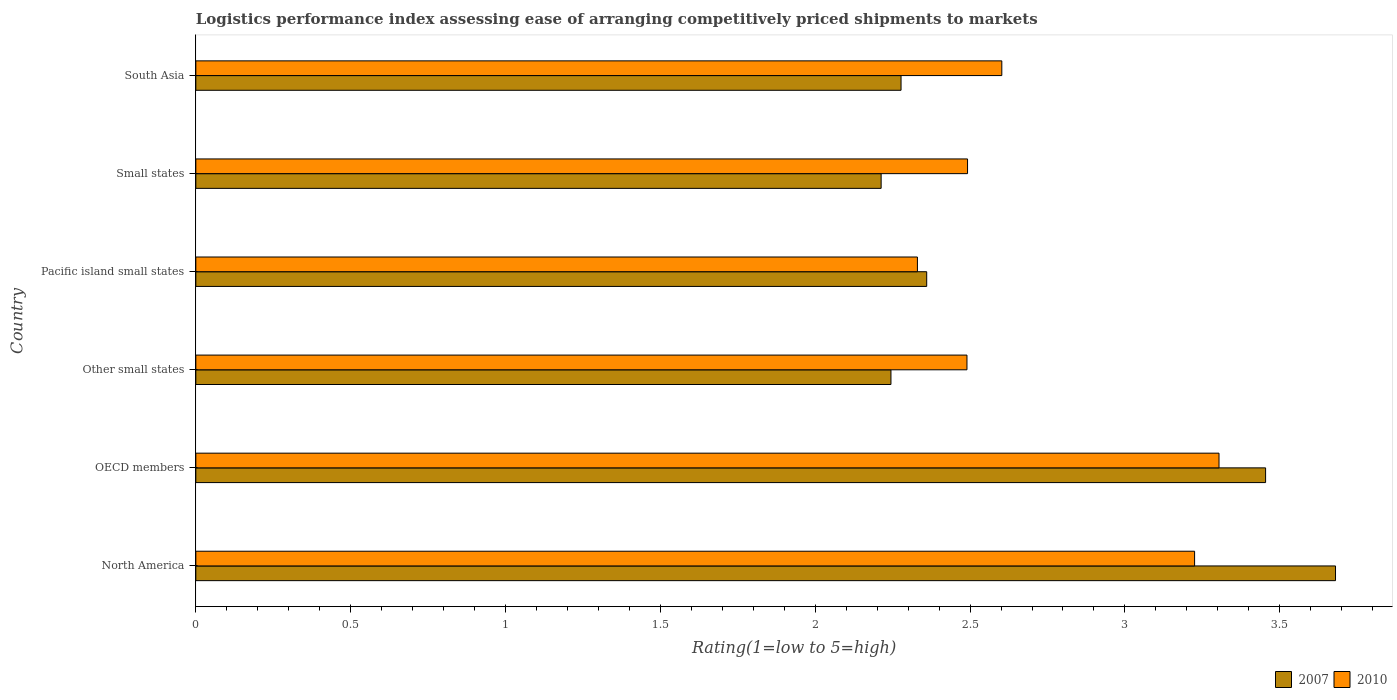How many groups of bars are there?
Offer a terse response. 6. What is the label of the 6th group of bars from the top?
Ensure brevity in your answer.  North America. In how many cases, is the number of bars for a given country not equal to the number of legend labels?
Provide a short and direct response. 0. What is the Logistic performance index in 2010 in North America?
Your answer should be very brief. 3.23. Across all countries, what is the maximum Logistic performance index in 2010?
Provide a succinct answer. 3.3. Across all countries, what is the minimum Logistic performance index in 2007?
Your answer should be compact. 2.21. In which country was the Logistic performance index in 2007 minimum?
Provide a short and direct response. Small states. What is the total Logistic performance index in 2007 in the graph?
Your answer should be very brief. 16.23. What is the difference between the Logistic performance index in 2010 in North America and that in Other small states?
Provide a short and direct response. 0.73. What is the difference between the Logistic performance index in 2010 in South Asia and the Logistic performance index in 2007 in OECD members?
Provide a short and direct response. -0.85. What is the average Logistic performance index in 2007 per country?
Your response must be concise. 2.7. What is the difference between the Logistic performance index in 2007 and Logistic performance index in 2010 in Other small states?
Offer a very short reply. -0.25. What is the ratio of the Logistic performance index in 2007 in Other small states to that in Small states?
Give a very brief answer. 1.01. Is the Logistic performance index in 2007 in OECD members less than that in Other small states?
Provide a succinct answer. No. What is the difference between the highest and the second highest Logistic performance index in 2007?
Offer a very short reply. 0.23. What is the difference between the highest and the lowest Logistic performance index in 2007?
Your answer should be very brief. 1.47. In how many countries, is the Logistic performance index in 2010 greater than the average Logistic performance index in 2010 taken over all countries?
Your answer should be very brief. 2. How many bars are there?
Your answer should be compact. 12. Are all the bars in the graph horizontal?
Give a very brief answer. Yes. How many countries are there in the graph?
Offer a very short reply. 6. Are the values on the major ticks of X-axis written in scientific E-notation?
Keep it short and to the point. No. Where does the legend appear in the graph?
Your answer should be very brief. Bottom right. How many legend labels are there?
Provide a short and direct response. 2. How are the legend labels stacked?
Ensure brevity in your answer.  Horizontal. What is the title of the graph?
Make the answer very short. Logistics performance index assessing ease of arranging competitively priced shipments to markets. What is the label or title of the X-axis?
Ensure brevity in your answer.  Rating(1=low to 5=high). What is the label or title of the Y-axis?
Make the answer very short. Country. What is the Rating(1=low to 5=high) in 2007 in North America?
Offer a very short reply. 3.68. What is the Rating(1=low to 5=high) in 2010 in North America?
Your response must be concise. 3.23. What is the Rating(1=low to 5=high) of 2007 in OECD members?
Offer a very short reply. 3.45. What is the Rating(1=low to 5=high) of 2010 in OECD members?
Your answer should be compact. 3.3. What is the Rating(1=low to 5=high) of 2007 in Other small states?
Give a very brief answer. 2.24. What is the Rating(1=low to 5=high) in 2010 in Other small states?
Offer a terse response. 2.49. What is the Rating(1=low to 5=high) of 2007 in Pacific island small states?
Ensure brevity in your answer.  2.36. What is the Rating(1=low to 5=high) in 2010 in Pacific island small states?
Offer a very short reply. 2.33. What is the Rating(1=low to 5=high) of 2007 in Small states?
Keep it short and to the point. 2.21. What is the Rating(1=low to 5=high) in 2010 in Small states?
Your response must be concise. 2.49. What is the Rating(1=low to 5=high) in 2007 in South Asia?
Keep it short and to the point. 2.28. What is the Rating(1=low to 5=high) in 2010 in South Asia?
Your answer should be compact. 2.6. Across all countries, what is the maximum Rating(1=low to 5=high) of 2007?
Your response must be concise. 3.68. Across all countries, what is the maximum Rating(1=low to 5=high) in 2010?
Your response must be concise. 3.3. Across all countries, what is the minimum Rating(1=low to 5=high) of 2007?
Your answer should be compact. 2.21. Across all countries, what is the minimum Rating(1=low to 5=high) of 2010?
Ensure brevity in your answer.  2.33. What is the total Rating(1=low to 5=high) of 2007 in the graph?
Provide a short and direct response. 16.23. What is the total Rating(1=low to 5=high) of 2010 in the graph?
Provide a short and direct response. 16.44. What is the difference between the Rating(1=low to 5=high) in 2007 in North America and that in OECD members?
Offer a very short reply. 0.23. What is the difference between the Rating(1=low to 5=high) in 2010 in North America and that in OECD members?
Make the answer very short. -0.08. What is the difference between the Rating(1=low to 5=high) in 2007 in North America and that in Other small states?
Your answer should be very brief. 1.44. What is the difference between the Rating(1=low to 5=high) of 2010 in North America and that in Other small states?
Offer a terse response. 0.73. What is the difference between the Rating(1=low to 5=high) of 2007 in North America and that in Pacific island small states?
Ensure brevity in your answer.  1.32. What is the difference between the Rating(1=low to 5=high) in 2010 in North America and that in Pacific island small states?
Make the answer very short. 0.9. What is the difference between the Rating(1=low to 5=high) of 2007 in North America and that in Small states?
Offer a very short reply. 1.47. What is the difference between the Rating(1=low to 5=high) in 2010 in North America and that in Small states?
Your answer should be very brief. 0.73. What is the difference between the Rating(1=low to 5=high) in 2007 in North America and that in South Asia?
Offer a very short reply. 1.4. What is the difference between the Rating(1=low to 5=high) in 2010 in North America and that in South Asia?
Make the answer very short. 0.62. What is the difference between the Rating(1=low to 5=high) in 2007 in OECD members and that in Other small states?
Offer a very short reply. 1.21. What is the difference between the Rating(1=low to 5=high) of 2010 in OECD members and that in Other small states?
Ensure brevity in your answer.  0.81. What is the difference between the Rating(1=low to 5=high) of 2007 in OECD members and that in Pacific island small states?
Offer a terse response. 1.09. What is the difference between the Rating(1=low to 5=high) of 2010 in OECD members and that in Pacific island small states?
Your answer should be very brief. 0.97. What is the difference between the Rating(1=low to 5=high) in 2007 in OECD members and that in Small states?
Provide a succinct answer. 1.24. What is the difference between the Rating(1=low to 5=high) in 2010 in OECD members and that in Small states?
Your answer should be very brief. 0.81. What is the difference between the Rating(1=low to 5=high) of 2007 in OECD members and that in South Asia?
Your answer should be compact. 1.18. What is the difference between the Rating(1=low to 5=high) in 2010 in OECD members and that in South Asia?
Give a very brief answer. 0.7. What is the difference between the Rating(1=low to 5=high) in 2007 in Other small states and that in Pacific island small states?
Make the answer very short. -0.12. What is the difference between the Rating(1=low to 5=high) in 2010 in Other small states and that in Pacific island small states?
Ensure brevity in your answer.  0.16. What is the difference between the Rating(1=low to 5=high) of 2007 in Other small states and that in Small states?
Provide a short and direct response. 0.03. What is the difference between the Rating(1=low to 5=high) in 2010 in Other small states and that in Small states?
Offer a very short reply. -0. What is the difference between the Rating(1=low to 5=high) in 2007 in Other small states and that in South Asia?
Ensure brevity in your answer.  -0.03. What is the difference between the Rating(1=low to 5=high) in 2010 in Other small states and that in South Asia?
Ensure brevity in your answer.  -0.11. What is the difference between the Rating(1=low to 5=high) of 2007 in Pacific island small states and that in Small states?
Your response must be concise. 0.15. What is the difference between the Rating(1=low to 5=high) of 2010 in Pacific island small states and that in Small states?
Your answer should be very brief. -0.16. What is the difference between the Rating(1=low to 5=high) in 2007 in Pacific island small states and that in South Asia?
Ensure brevity in your answer.  0.08. What is the difference between the Rating(1=low to 5=high) in 2010 in Pacific island small states and that in South Asia?
Your answer should be very brief. -0.27. What is the difference between the Rating(1=low to 5=high) of 2007 in Small states and that in South Asia?
Ensure brevity in your answer.  -0.06. What is the difference between the Rating(1=low to 5=high) of 2010 in Small states and that in South Asia?
Your answer should be compact. -0.11. What is the difference between the Rating(1=low to 5=high) in 2007 in North America and the Rating(1=low to 5=high) in 2010 in OECD members?
Keep it short and to the point. 0.38. What is the difference between the Rating(1=low to 5=high) of 2007 in North America and the Rating(1=low to 5=high) of 2010 in Other small states?
Keep it short and to the point. 1.19. What is the difference between the Rating(1=low to 5=high) of 2007 in North America and the Rating(1=low to 5=high) of 2010 in Pacific island small states?
Offer a terse response. 1.35. What is the difference between the Rating(1=low to 5=high) in 2007 in North America and the Rating(1=low to 5=high) in 2010 in Small states?
Your answer should be compact. 1.19. What is the difference between the Rating(1=low to 5=high) in 2007 in North America and the Rating(1=low to 5=high) in 2010 in South Asia?
Provide a short and direct response. 1.08. What is the difference between the Rating(1=low to 5=high) of 2007 in OECD members and the Rating(1=low to 5=high) of 2010 in Other small states?
Your response must be concise. 0.96. What is the difference between the Rating(1=low to 5=high) of 2007 in OECD members and the Rating(1=low to 5=high) of 2010 in Pacific island small states?
Your answer should be very brief. 1.12. What is the difference between the Rating(1=low to 5=high) in 2007 in OECD members and the Rating(1=low to 5=high) in 2010 in Small states?
Provide a succinct answer. 0.96. What is the difference between the Rating(1=low to 5=high) of 2007 in OECD members and the Rating(1=low to 5=high) of 2010 in South Asia?
Ensure brevity in your answer.  0.85. What is the difference between the Rating(1=low to 5=high) of 2007 in Other small states and the Rating(1=low to 5=high) of 2010 in Pacific island small states?
Provide a short and direct response. -0.09. What is the difference between the Rating(1=low to 5=high) of 2007 in Other small states and the Rating(1=low to 5=high) of 2010 in Small states?
Provide a succinct answer. -0.25. What is the difference between the Rating(1=low to 5=high) in 2007 in Other small states and the Rating(1=low to 5=high) in 2010 in South Asia?
Offer a very short reply. -0.36. What is the difference between the Rating(1=low to 5=high) in 2007 in Pacific island small states and the Rating(1=low to 5=high) in 2010 in Small states?
Give a very brief answer. -0.13. What is the difference between the Rating(1=low to 5=high) in 2007 in Pacific island small states and the Rating(1=low to 5=high) in 2010 in South Asia?
Offer a very short reply. -0.24. What is the difference between the Rating(1=low to 5=high) in 2007 in Small states and the Rating(1=low to 5=high) in 2010 in South Asia?
Make the answer very short. -0.39. What is the average Rating(1=low to 5=high) in 2007 per country?
Your response must be concise. 2.7. What is the average Rating(1=low to 5=high) of 2010 per country?
Provide a short and direct response. 2.74. What is the difference between the Rating(1=low to 5=high) of 2007 and Rating(1=low to 5=high) of 2010 in North America?
Your answer should be compact. 0.46. What is the difference between the Rating(1=low to 5=high) of 2007 and Rating(1=low to 5=high) of 2010 in OECD members?
Offer a very short reply. 0.15. What is the difference between the Rating(1=low to 5=high) in 2007 and Rating(1=low to 5=high) in 2010 in Other small states?
Provide a succinct answer. -0.25. What is the difference between the Rating(1=low to 5=high) in 2007 and Rating(1=low to 5=high) in 2010 in Pacific island small states?
Make the answer very short. 0.03. What is the difference between the Rating(1=low to 5=high) of 2007 and Rating(1=low to 5=high) of 2010 in Small states?
Provide a short and direct response. -0.28. What is the difference between the Rating(1=low to 5=high) of 2007 and Rating(1=low to 5=high) of 2010 in South Asia?
Provide a short and direct response. -0.33. What is the ratio of the Rating(1=low to 5=high) of 2007 in North America to that in OECD members?
Ensure brevity in your answer.  1.07. What is the ratio of the Rating(1=low to 5=high) in 2010 in North America to that in OECD members?
Provide a succinct answer. 0.98. What is the ratio of the Rating(1=low to 5=high) of 2007 in North America to that in Other small states?
Provide a short and direct response. 1.64. What is the ratio of the Rating(1=low to 5=high) in 2010 in North America to that in Other small states?
Your answer should be very brief. 1.3. What is the ratio of the Rating(1=low to 5=high) in 2007 in North America to that in Pacific island small states?
Keep it short and to the point. 1.56. What is the ratio of the Rating(1=low to 5=high) in 2010 in North America to that in Pacific island small states?
Offer a terse response. 1.38. What is the ratio of the Rating(1=low to 5=high) of 2007 in North America to that in Small states?
Provide a succinct answer. 1.66. What is the ratio of the Rating(1=low to 5=high) in 2010 in North America to that in Small states?
Your answer should be compact. 1.29. What is the ratio of the Rating(1=low to 5=high) in 2007 in North America to that in South Asia?
Provide a succinct answer. 1.62. What is the ratio of the Rating(1=low to 5=high) of 2010 in North America to that in South Asia?
Give a very brief answer. 1.24. What is the ratio of the Rating(1=low to 5=high) in 2007 in OECD members to that in Other small states?
Provide a short and direct response. 1.54. What is the ratio of the Rating(1=low to 5=high) in 2010 in OECD members to that in Other small states?
Your answer should be very brief. 1.33. What is the ratio of the Rating(1=low to 5=high) of 2007 in OECD members to that in Pacific island small states?
Your answer should be compact. 1.46. What is the ratio of the Rating(1=low to 5=high) in 2010 in OECD members to that in Pacific island small states?
Offer a very short reply. 1.42. What is the ratio of the Rating(1=low to 5=high) of 2007 in OECD members to that in Small states?
Offer a very short reply. 1.56. What is the ratio of the Rating(1=low to 5=high) in 2010 in OECD members to that in Small states?
Provide a succinct answer. 1.33. What is the ratio of the Rating(1=low to 5=high) of 2007 in OECD members to that in South Asia?
Your response must be concise. 1.52. What is the ratio of the Rating(1=low to 5=high) of 2010 in OECD members to that in South Asia?
Provide a short and direct response. 1.27. What is the ratio of the Rating(1=low to 5=high) in 2007 in Other small states to that in Pacific island small states?
Ensure brevity in your answer.  0.95. What is the ratio of the Rating(1=low to 5=high) of 2010 in Other small states to that in Pacific island small states?
Keep it short and to the point. 1.07. What is the ratio of the Rating(1=low to 5=high) of 2007 in Other small states to that in Small states?
Your answer should be compact. 1.01. What is the ratio of the Rating(1=low to 5=high) in 2010 in Other small states to that in Small states?
Your answer should be very brief. 1. What is the ratio of the Rating(1=low to 5=high) in 2007 in Other small states to that in South Asia?
Your response must be concise. 0.99. What is the ratio of the Rating(1=low to 5=high) of 2010 in Other small states to that in South Asia?
Provide a succinct answer. 0.96. What is the ratio of the Rating(1=low to 5=high) in 2007 in Pacific island small states to that in Small states?
Make the answer very short. 1.07. What is the ratio of the Rating(1=low to 5=high) in 2010 in Pacific island small states to that in Small states?
Give a very brief answer. 0.94. What is the ratio of the Rating(1=low to 5=high) of 2007 in Pacific island small states to that in South Asia?
Offer a terse response. 1.04. What is the ratio of the Rating(1=low to 5=high) in 2010 in Pacific island small states to that in South Asia?
Give a very brief answer. 0.9. What is the ratio of the Rating(1=low to 5=high) in 2007 in Small states to that in South Asia?
Provide a succinct answer. 0.97. What is the ratio of the Rating(1=low to 5=high) of 2010 in Small states to that in South Asia?
Make the answer very short. 0.96. What is the difference between the highest and the second highest Rating(1=low to 5=high) of 2007?
Keep it short and to the point. 0.23. What is the difference between the highest and the second highest Rating(1=low to 5=high) of 2010?
Give a very brief answer. 0.08. What is the difference between the highest and the lowest Rating(1=low to 5=high) of 2007?
Provide a short and direct response. 1.47. What is the difference between the highest and the lowest Rating(1=low to 5=high) in 2010?
Make the answer very short. 0.97. 